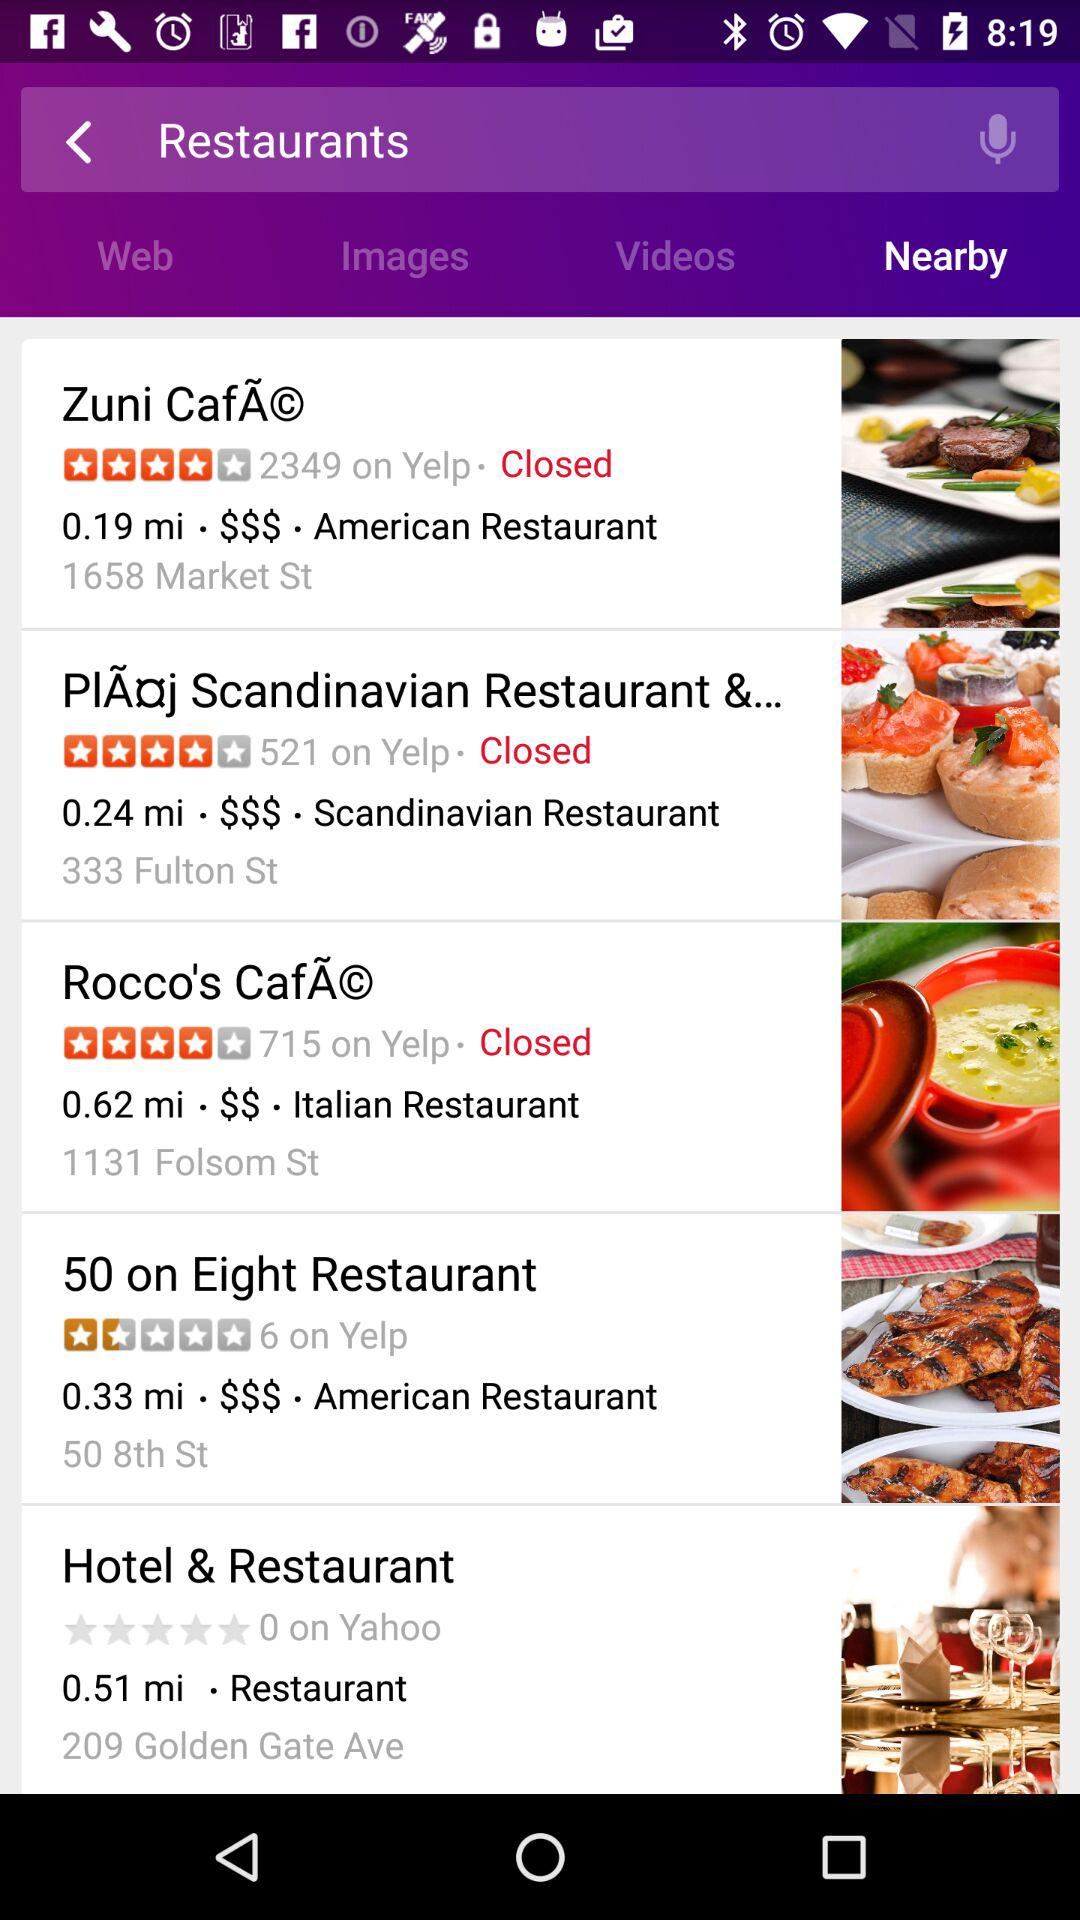What's the name of the Italian restaurant? The name of the Italian restaurant is "Rocco's CafÃ©". 